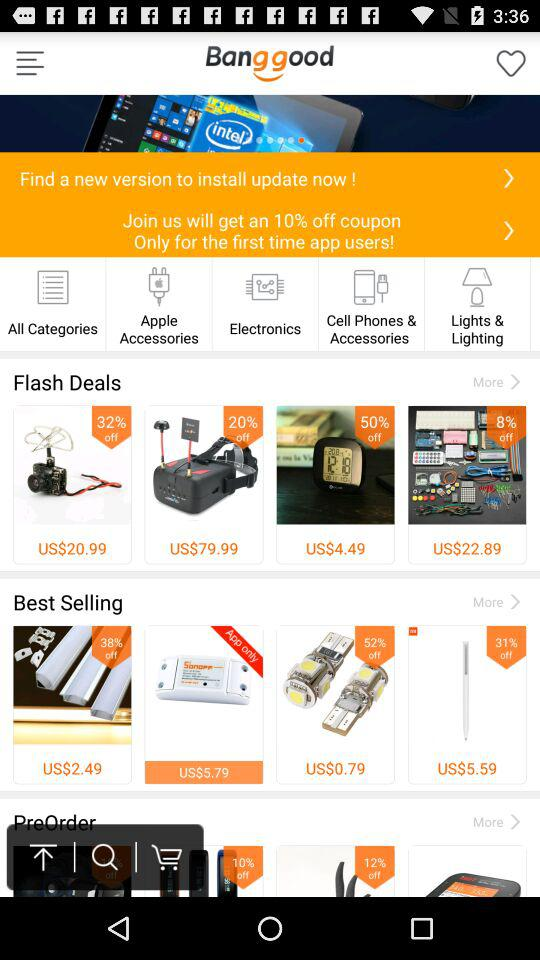The costs are stated in what currency? The costs are stated in US dollars. 